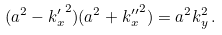Convert formula to latex. <formula><loc_0><loc_0><loc_500><loc_500>( a ^ { 2 } - { k ^ { \prime } _ { x } } ^ { 2 } ) ( a ^ { 2 } + { k ^ { \prime \prime } _ { x } } ^ { 2 } ) = a ^ { 2 } k _ { y } ^ { 2 } \, .</formula> 